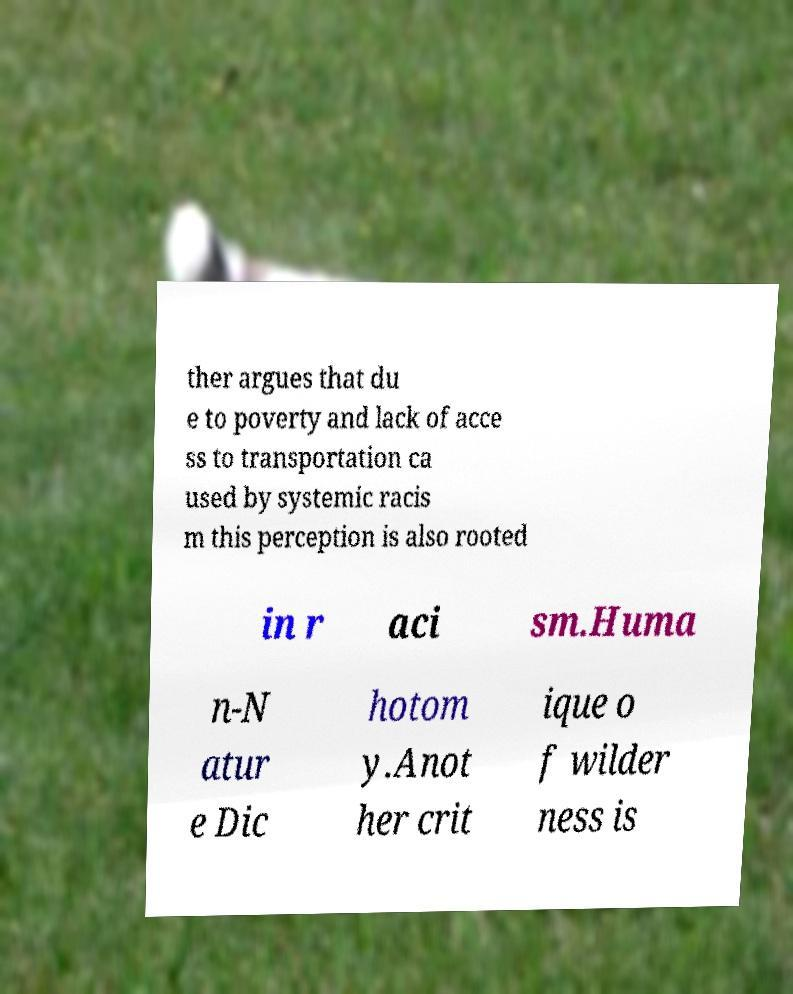For documentation purposes, I need the text within this image transcribed. Could you provide that? ther argues that du e to poverty and lack of acce ss to transportation ca used by systemic racis m this perception is also rooted in r aci sm.Huma n-N atur e Dic hotom y.Anot her crit ique o f wilder ness is 